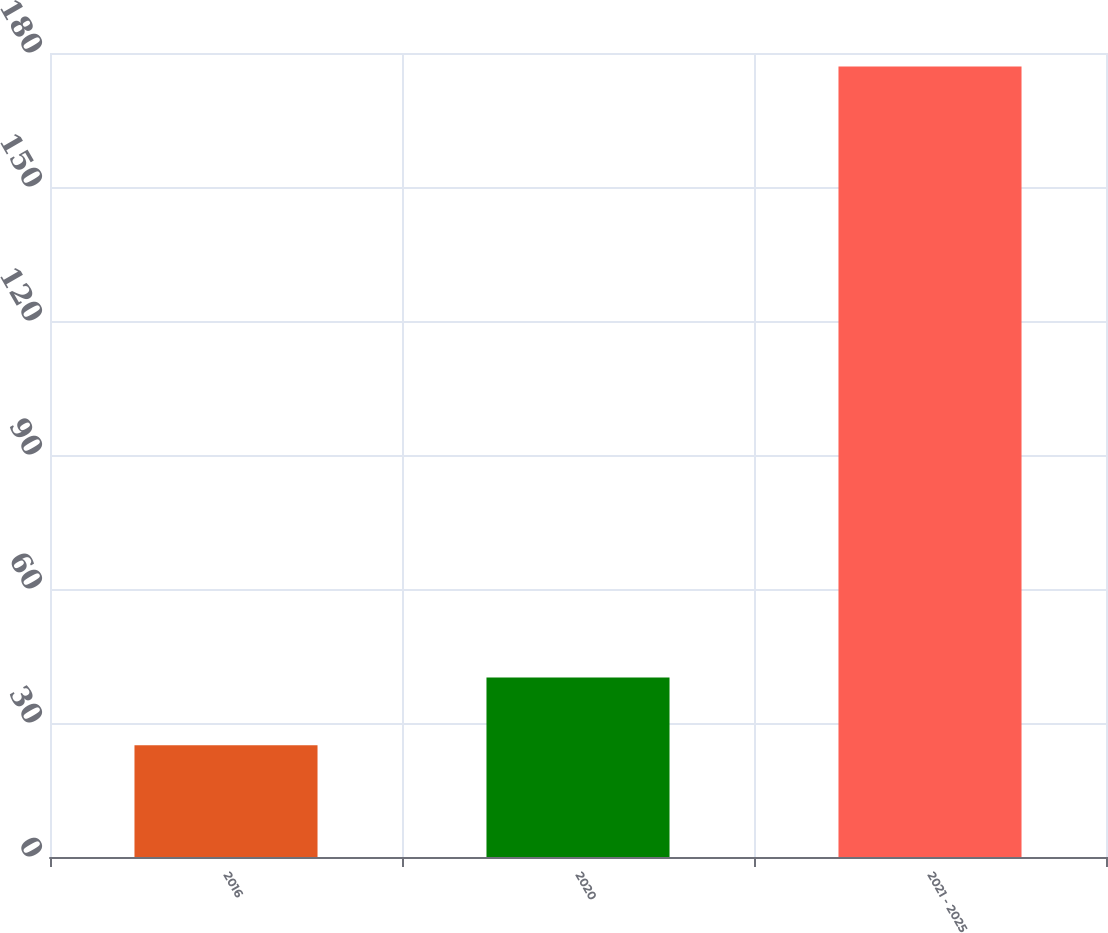Convert chart to OTSL. <chart><loc_0><loc_0><loc_500><loc_500><bar_chart><fcel>2016<fcel>2020<fcel>2021 - 2025<nl><fcel>25<fcel>40.2<fcel>177<nl></chart> 